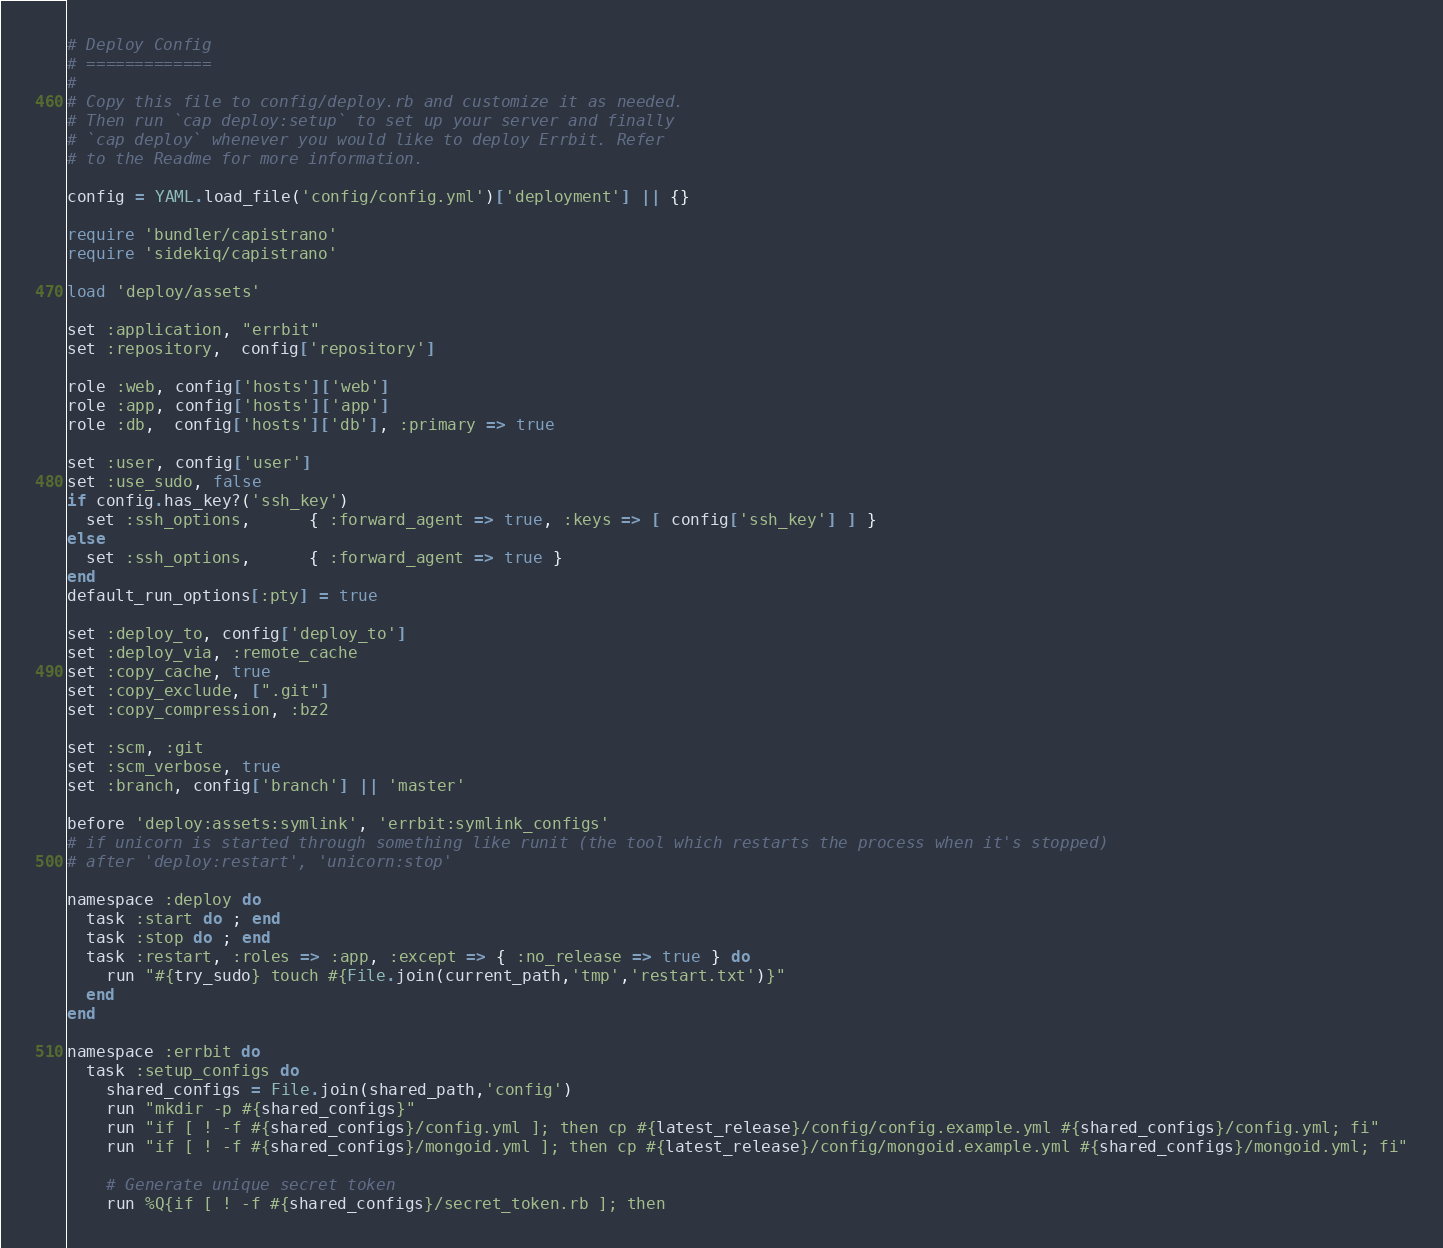Convert code to text. <code><loc_0><loc_0><loc_500><loc_500><_Ruby_># Deploy Config
# =============
#
# Copy this file to config/deploy.rb and customize it as needed.
# Then run `cap deploy:setup` to set up your server and finally
# `cap deploy` whenever you would like to deploy Errbit. Refer
# to the Readme for more information.

config = YAML.load_file('config/config.yml')['deployment'] || {}

require 'bundler/capistrano'
require 'sidekiq/capistrano'

load 'deploy/assets'

set :application, "errbit"
set :repository,  config['repository']

role :web, config['hosts']['web']
role :app, config['hosts']['app']
role :db,  config['hosts']['db'], :primary => true

set :user, config['user']
set :use_sudo, false
if config.has_key?('ssh_key')
  set :ssh_options,      { :forward_agent => true, :keys => [ config['ssh_key'] ] }
else
  set :ssh_options,      { :forward_agent => true }
end
default_run_options[:pty] = true

set :deploy_to, config['deploy_to']
set :deploy_via, :remote_cache
set :copy_cache, true
set :copy_exclude, [".git"]
set :copy_compression, :bz2

set :scm, :git
set :scm_verbose, true
set :branch, config['branch'] || 'master'

before 'deploy:assets:symlink', 'errbit:symlink_configs'
# if unicorn is started through something like runit (the tool which restarts the process when it's stopped)
# after 'deploy:restart', 'unicorn:stop'

namespace :deploy do
  task :start do ; end
  task :stop do ; end
  task :restart, :roles => :app, :except => { :no_release => true } do
    run "#{try_sudo} touch #{File.join(current_path,'tmp','restart.txt')}"
  end
end

namespace :errbit do
  task :setup_configs do
    shared_configs = File.join(shared_path,'config')
    run "mkdir -p #{shared_configs}"
    run "if [ ! -f #{shared_configs}/config.yml ]; then cp #{latest_release}/config/config.example.yml #{shared_configs}/config.yml; fi"
    run "if [ ! -f #{shared_configs}/mongoid.yml ]; then cp #{latest_release}/config/mongoid.example.yml #{shared_configs}/mongoid.yml; fi"

    # Generate unique secret token
    run %Q{if [ ! -f #{shared_configs}/secret_token.rb ]; then</code> 